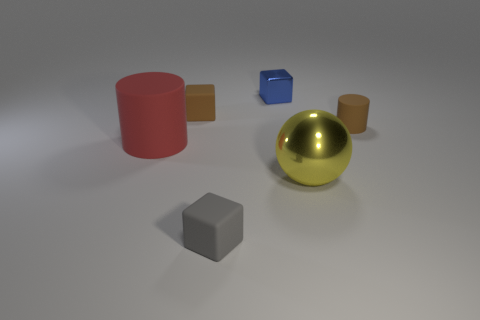Is the number of large cylinders greater than the number of purple blocks?
Ensure brevity in your answer.  Yes. How many other things are made of the same material as the yellow thing?
Your answer should be very brief. 1. How many objects are either gray things or matte cylinders behind the red matte object?
Provide a succinct answer. 2. Are there fewer small brown matte cubes than big red metallic objects?
Your response must be concise. No. The metallic cube that is behind the small rubber thing in front of the tiny rubber thing on the right side of the gray matte object is what color?
Your answer should be very brief. Blue. Are the tiny blue block and the small brown block made of the same material?
Ensure brevity in your answer.  No. There is a tiny shiny thing; what number of rubber cylinders are right of it?
Ensure brevity in your answer.  1. The other rubber thing that is the same shape as the big red thing is what size?
Provide a short and direct response. Small. How many brown things are either tiny cylinders or tiny matte things?
Provide a short and direct response. 2. There is a small thing that is in front of the big yellow thing; how many tiny matte cylinders are in front of it?
Offer a very short reply. 0. 